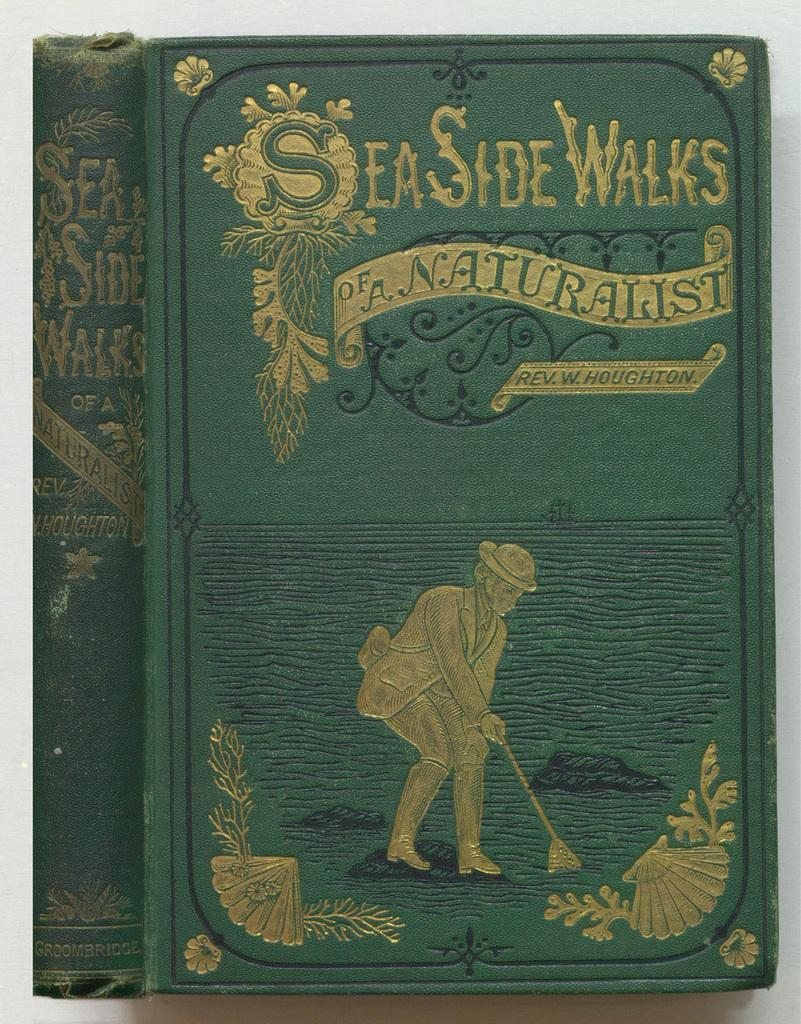<image>
Offer a succinct explanation of the picture presented. An old leather bound green book shows its title "Seaside walks" engraved in gold. 